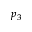<formula> <loc_0><loc_0><loc_500><loc_500>p _ { 3 }</formula> 